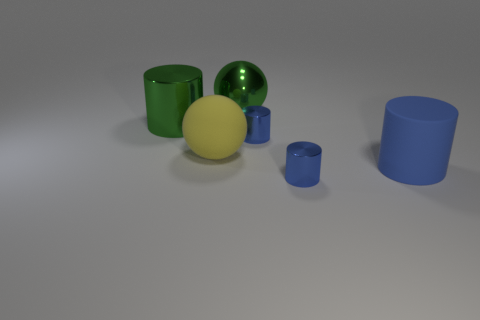Subtract all blue spheres. How many blue cylinders are left? 3 Subtract all green cylinders. How many cylinders are left? 3 Subtract all big green shiny cylinders. How many cylinders are left? 3 Subtract all red cylinders. Subtract all blue spheres. How many cylinders are left? 4 Add 2 large green metallic spheres. How many objects exist? 8 Subtract all spheres. How many objects are left? 4 Subtract all metal cubes. Subtract all big green shiny objects. How many objects are left? 4 Add 3 blue matte objects. How many blue matte objects are left? 4 Add 3 yellow matte things. How many yellow matte things exist? 4 Subtract 1 green cylinders. How many objects are left? 5 